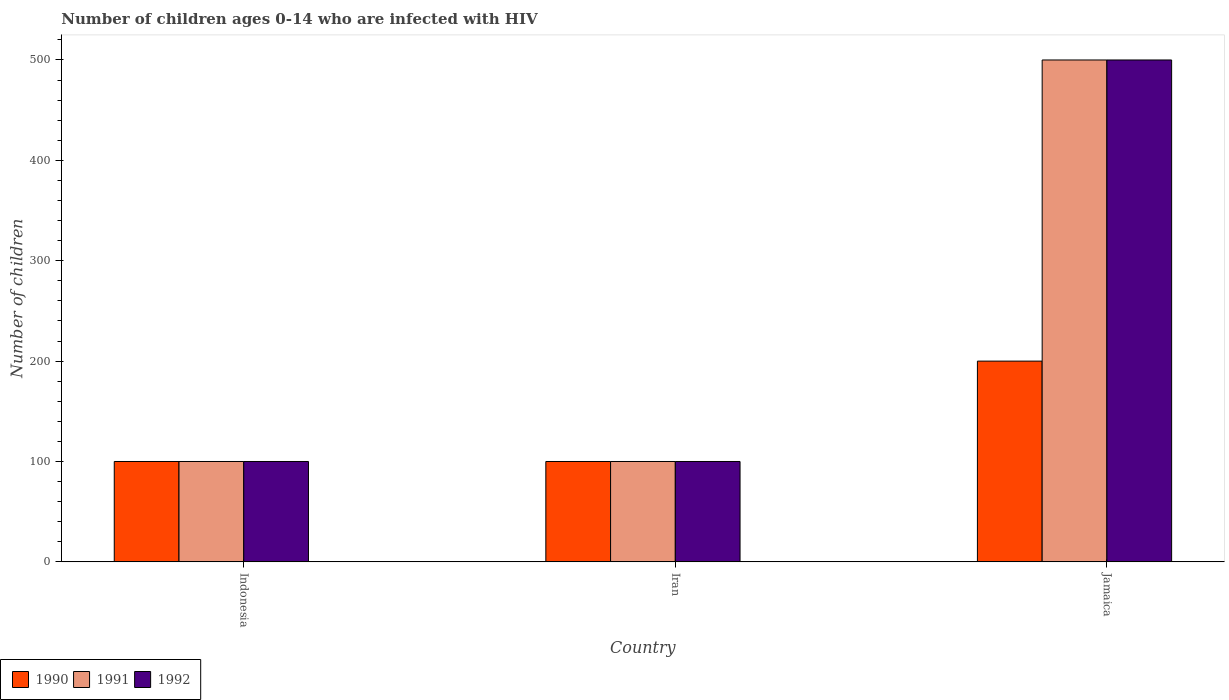How many different coloured bars are there?
Your response must be concise. 3. How many groups of bars are there?
Give a very brief answer. 3. Are the number of bars on each tick of the X-axis equal?
Your answer should be compact. Yes. How many bars are there on the 2nd tick from the left?
Ensure brevity in your answer.  3. What is the label of the 1st group of bars from the left?
Offer a terse response. Indonesia. In how many cases, is the number of bars for a given country not equal to the number of legend labels?
Provide a short and direct response. 0. What is the number of HIV infected children in 1992 in Iran?
Offer a very short reply. 100. Across all countries, what is the maximum number of HIV infected children in 1990?
Make the answer very short. 200. Across all countries, what is the minimum number of HIV infected children in 1992?
Ensure brevity in your answer.  100. In which country was the number of HIV infected children in 1990 maximum?
Provide a succinct answer. Jamaica. In which country was the number of HIV infected children in 1991 minimum?
Make the answer very short. Indonesia. What is the total number of HIV infected children in 1992 in the graph?
Make the answer very short. 700. What is the difference between the number of HIV infected children in 1990 in Indonesia and that in Jamaica?
Provide a succinct answer. -100. What is the difference between the number of HIV infected children in 1992 in Indonesia and the number of HIV infected children in 1990 in Jamaica?
Ensure brevity in your answer.  -100. What is the average number of HIV infected children in 1991 per country?
Make the answer very short. 233.33. What is the difference between the number of HIV infected children of/in 1990 and number of HIV infected children of/in 1992 in Indonesia?
Make the answer very short. 0. Is the difference between the number of HIV infected children in 1990 in Indonesia and Jamaica greater than the difference between the number of HIV infected children in 1992 in Indonesia and Jamaica?
Offer a terse response. Yes. What is the difference between the highest and the second highest number of HIV infected children in 1991?
Provide a short and direct response. -400. What is the difference between the highest and the lowest number of HIV infected children in 1992?
Ensure brevity in your answer.  400. Is the sum of the number of HIV infected children in 1992 in Indonesia and Jamaica greater than the maximum number of HIV infected children in 1991 across all countries?
Your answer should be very brief. Yes. Is it the case that in every country, the sum of the number of HIV infected children in 1990 and number of HIV infected children in 1992 is greater than the number of HIV infected children in 1991?
Provide a short and direct response. Yes. Are all the bars in the graph horizontal?
Make the answer very short. No. How many countries are there in the graph?
Ensure brevity in your answer.  3. Does the graph contain grids?
Offer a terse response. No. How are the legend labels stacked?
Keep it short and to the point. Horizontal. What is the title of the graph?
Provide a succinct answer. Number of children ages 0-14 who are infected with HIV. Does "1963" appear as one of the legend labels in the graph?
Your answer should be compact. No. What is the label or title of the Y-axis?
Keep it short and to the point. Number of children. What is the Number of children in 1990 in Indonesia?
Offer a terse response. 100. What is the Number of children in 1992 in Indonesia?
Offer a terse response. 100. What is the Number of children in 1990 in Iran?
Make the answer very short. 100. What is the Number of children of 1992 in Iran?
Your response must be concise. 100. Across all countries, what is the maximum Number of children in 1991?
Your answer should be compact. 500. Across all countries, what is the maximum Number of children of 1992?
Keep it short and to the point. 500. What is the total Number of children in 1990 in the graph?
Offer a terse response. 400. What is the total Number of children of 1991 in the graph?
Provide a short and direct response. 700. What is the total Number of children in 1992 in the graph?
Ensure brevity in your answer.  700. What is the difference between the Number of children in 1990 in Indonesia and that in Jamaica?
Give a very brief answer. -100. What is the difference between the Number of children of 1991 in Indonesia and that in Jamaica?
Your response must be concise. -400. What is the difference between the Number of children of 1992 in Indonesia and that in Jamaica?
Make the answer very short. -400. What is the difference between the Number of children in 1990 in Iran and that in Jamaica?
Your response must be concise. -100. What is the difference between the Number of children in 1991 in Iran and that in Jamaica?
Your answer should be compact. -400. What is the difference between the Number of children in 1992 in Iran and that in Jamaica?
Provide a short and direct response. -400. What is the difference between the Number of children in 1990 in Indonesia and the Number of children in 1991 in Jamaica?
Offer a terse response. -400. What is the difference between the Number of children of 1990 in Indonesia and the Number of children of 1992 in Jamaica?
Provide a succinct answer. -400. What is the difference between the Number of children of 1991 in Indonesia and the Number of children of 1992 in Jamaica?
Give a very brief answer. -400. What is the difference between the Number of children of 1990 in Iran and the Number of children of 1991 in Jamaica?
Offer a terse response. -400. What is the difference between the Number of children of 1990 in Iran and the Number of children of 1992 in Jamaica?
Give a very brief answer. -400. What is the difference between the Number of children in 1991 in Iran and the Number of children in 1992 in Jamaica?
Offer a terse response. -400. What is the average Number of children of 1990 per country?
Your answer should be compact. 133.33. What is the average Number of children of 1991 per country?
Provide a short and direct response. 233.33. What is the average Number of children of 1992 per country?
Provide a short and direct response. 233.33. What is the difference between the Number of children in 1990 and Number of children in 1991 in Indonesia?
Make the answer very short. 0. What is the difference between the Number of children in 1990 and Number of children in 1992 in Indonesia?
Your answer should be compact. 0. What is the difference between the Number of children in 1990 and Number of children in 1991 in Iran?
Provide a short and direct response. 0. What is the difference between the Number of children of 1990 and Number of children of 1992 in Iran?
Provide a short and direct response. 0. What is the difference between the Number of children in 1990 and Number of children in 1991 in Jamaica?
Ensure brevity in your answer.  -300. What is the difference between the Number of children in 1990 and Number of children in 1992 in Jamaica?
Give a very brief answer. -300. What is the ratio of the Number of children of 1992 in Indonesia to that in Iran?
Make the answer very short. 1. What is the ratio of the Number of children of 1990 in Indonesia to that in Jamaica?
Provide a short and direct response. 0.5. What is the ratio of the Number of children in 1991 in Indonesia to that in Jamaica?
Your answer should be very brief. 0.2. What is the ratio of the Number of children of 1990 in Iran to that in Jamaica?
Give a very brief answer. 0.5. What is the ratio of the Number of children in 1992 in Iran to that in Jamaica?
Ensure brevity in your answer.  0.2. What is the difference between the highest and the second highest Number of children in 1991?
Make the answer very short. 400. What is the difference between the highest and the lowest Number of children in 1990?
Provide a short and direct response. 100. What is the difference between the highest and the lowest Number of children of 1991?
Your answer should be compact. 400. What is the difference between the highest and the lowest Number of children in 1992?
Your answer should be very brief. 400. 